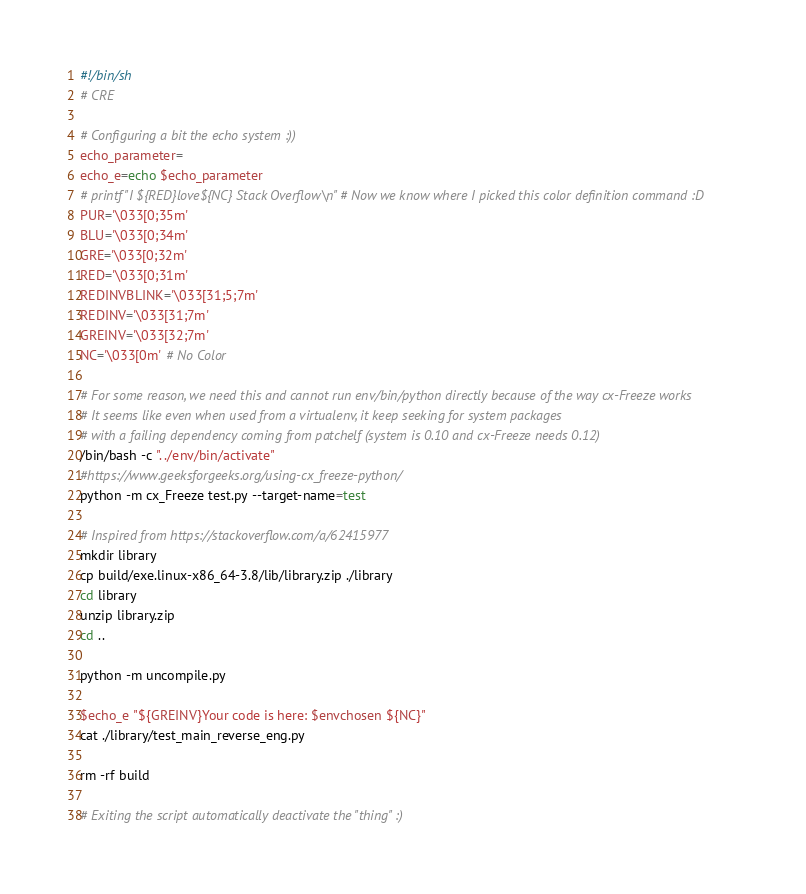<code> <loc_0><loc_0><loc_500><loc_500><_Bash_>#!/bin/sh
# CRE

# Configuring a bit the echo system :))
echo_parameter=
echo_e=echo $echo_parameter
# printf "I ${RED}love${NC} Stack Overflow\n" # Now we know where I picked this color definition command :D
PUR='\033[0;35m'
BLU='\033[0;34m'
GRE='\033[0;32m'
RED='\033[0;31m'
REDINVBLINK='\033[31;5;7m'
REDINV='\033[31;7m'
GREINV='\033[32;7m'
NC='\033[0m' # No Color

# For some reason, we need this and cannot run env/bin/python directly because of the way cx-Freeze works
# It seems like even when used from a virtualenv, it keep seeking for system packages
# with a failing dependency coming from patchelf (system is 0.10 and cx-Freeze needs 0.12)
/bin/bash -c ". ./env/bin/activate"
#https://www.geeksforgeeks.org/using-cx_freeze-python/
python -m cx_Freeze test.py --target-name=test

# Inspired from https://stackoverflow.com/a/62415977
mkdir library
cp build/exe.linux-x86_64-3.8/lib/library.zip ./library
cd library
unzip library.zip
cd ..

python -m uncompile.py

$echo_e "${GREINV}Your code is here: $envchosen ${NC}"
cat ./library/test_main_reverse_eng.py

rm -rf build

# Exiting the script automatically deactivate the "thing" :)</code> 